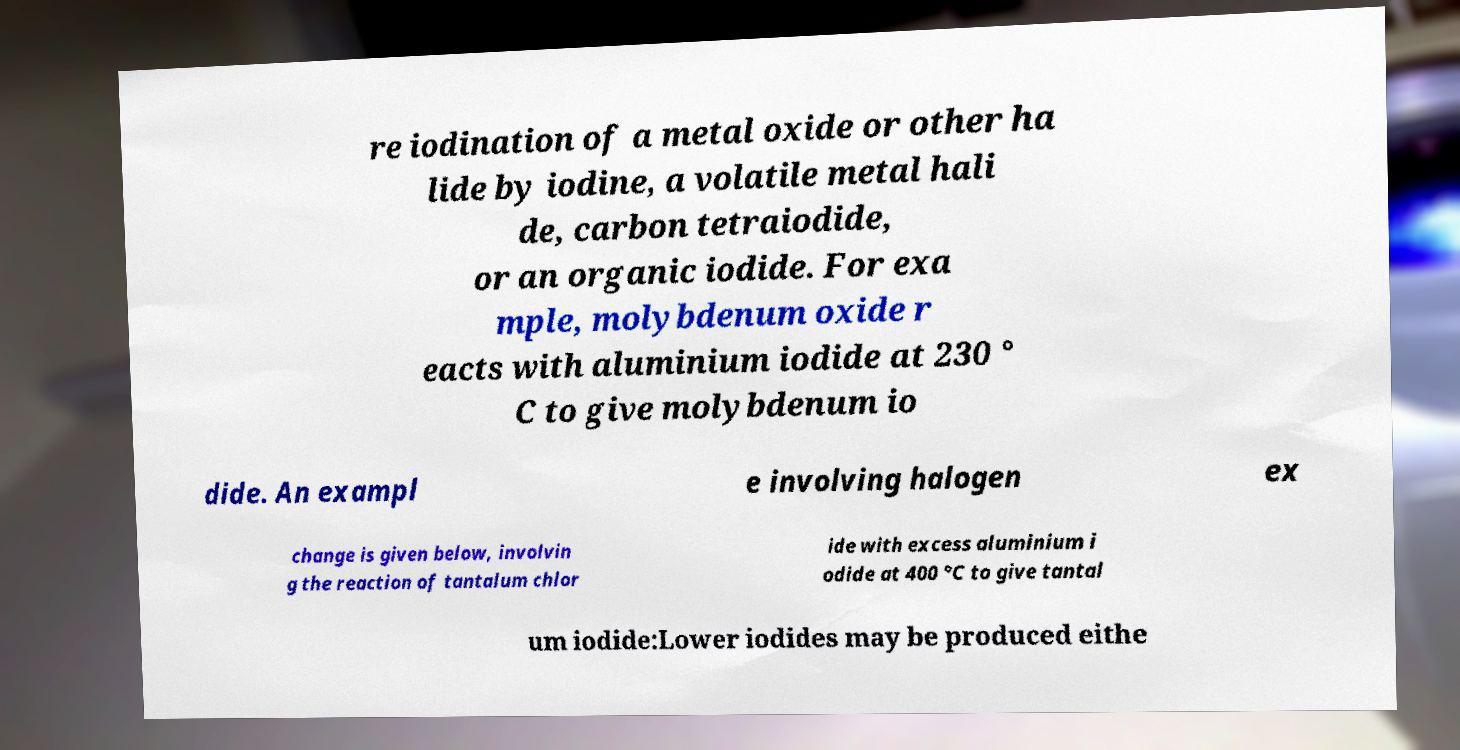Please identify and transcribe the text found in this image. re iodination of a metal oxide or other ha lide by iodine, a volatile metal hali de, carbon tetraiodide, or an organic iodide. For exa mple, molybdenum oxide r eacts with aluminium iodide at 230 ° C to give molybdenum io dide. An exampl e involving halogen ex change is given below, involvin g the reaction of tantalum chlor ide with excess aluminium i odide at 400 °C to give tantal um iodide:Lower iodides may be produced eithe 